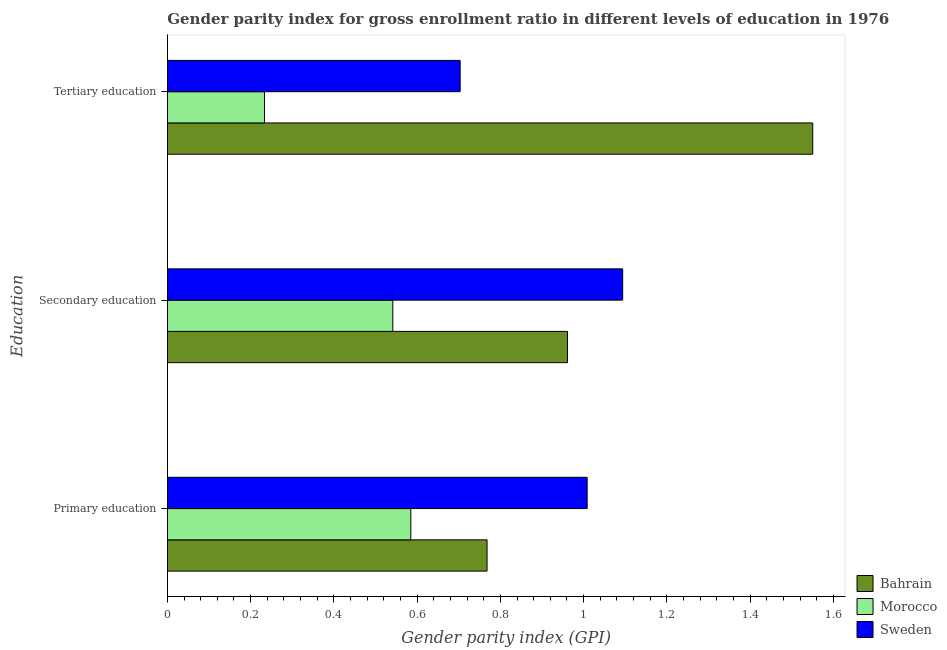How many different coloured bars are there?
Ensure brevity in your answer.  3. How many groups of bars are there?
Your answer should be very brief. 3. How many bars are there on the 2nd tick from the top?
Make the answer very short. 3. How many bars are there on the 1st tick from the bottom?
Keep it short and to the point. 3. What is the gender parity index in tertiary education in Sweden?
Your answer should be very brief. 0.7. Across all countries, what is the maximum gender parity index in secondary education?
Offer a terse response. 1.09. Across all countries, what is the minimum gender parity index in secondary education?
Your answer should be compact. 0.54. In which country was the gender parity index in primary education maximum?
Keep it short and to the point. Sweden. In which country was the gender parity index in secondary education minimum?
Offer a very short reply. Morocco. What is the total gender parity index in tertiary education in the graph?
Keep it short and to the point. 2.49. What is the difference between the gender parity index in tertiary education in Sweden and that in Morocco?
Ensure brevity in your answer.  0.47. What is the difference between the gender parity index in tertiary education in Bahrain and the gender parity index in primary education in Sweden?
Ensure brevity in your answer.  0.54. What is the average gender parity index in primary education per country?
Offer a very short reply. 0.79. What is the difference between the gender parity index in secondary education and gender parity index in primary education in Sweden?
Offer a terse response. 0.09. What is the ratio of the gender parity index in secondary education in Sweden to that in Bahrain?
Offer a very short reply. 1.14. What is the difference between the highest and the second highest gender parity index in tertiary education?
Offer a terse response. 0.85. What is the difference between the highest and the lowest gender parity index in tertiary education?
Your answer should be compact. 1.32. In how many countries, is the gender parity index in secondary education greater than the average gender parity index in secondary education taken over all countries?
Your answer should be compact. 2. What does the 3rd bar from the top in Primary education represents?
Provide a succinct answer. Bahrain. What does the 2nd bar from the bottom in Secondary education represents?
Provide a short and direct response. Morocco. Is it the case that in every country, the sum of the gender parity index in primary education and gender parity index in secondary education is greater than the gender parity index in tertiary education?
Make the answer very short. Yes. Are all the bars in the graph horizontal?
Make the answer very short. Yes. How many countries are there in the graph?
Provide a succinct answer. 3. Are the values on the major ticks of X-axis written in scientific E-notation?
Give a very brief answer. No. Does the graph contain any zero values?
Provide a short and direct response. No. Does the graph contain grids?
Ensure brevity in your answer.  No. Where does the legend appear in the graph?
Your answer should be compact. Bottom right. What is the title of the graph?
Provide a short and direct response. Gender parity index for gross enrollment ratio in different levels of education in 1976. Does "New Caledonia" appear as one of the legend labels in the graph?
Your answer should be compact. No. What is the label or title of the X-axis?
Offer a terse response. Gender parity index (GPI). What is the label or title of the Y-axis?
Make the answer very short. Education. What is the Gender parity index (GPI) of Bahrain in Primary education?
Offer a terse response. 0.77. What is the Gender parity index (GPI) of Morocco in Primary education?
Keep it short and to the point. 0.58. What is the Gender parity index (GPI) of Sweden in Primary education?
Make the answer very short. 1.01. What is the Gender parity index (GPI) in Bahrain in Secondary education?
Your response must be concise. 0.96. What is the Gender parity index (GPI) in Morocco in Secondary education?
Offer a terse response. 0.54. What is the Gender parity index (GPI) in Sweden in Secondary education?
Your answer should be compact. 1.09. What is the Gender parity index (GPI) in Bahrain in Tertiary education?
Make the answer very short. 1.55. What is the Gender parity index (GPI) of Morocco in Tertiary education?
Give a very brief answer. 0.23. What is the Gender parity index (GPI) in Sweden in Tertiary education?
Your answer should be compact. 0.7. Across all Education, what is the maximum Gender parity index (GPI) of Bahrain?
Provide a succinct answer. 1.55. Across all Education, what is the maximum Gender parity index (GPI) in Morocco?
Give a very brief answer. 0.58. Across all Education, what is the maximum Gender parity index (GPI) in Sweden?
Keep it short and to the point. 1.09. Across all Education, what is the minimum Gender parity index (GPI) in Bahrain?
Offer a very short reply. 0.77. Across all Education, what is the minimum Gender parity index (GPI) of Morocco?
Offer a terse response. 0.23. Across all Education, what is the minimum Gender parity index (GPI) of Sweden?
Make the answer very short. 0.7. What is the total Gender parity index (GPI) in Bahrain in the graph?
Offer a terse response. 3.28. What is the total Gender parity index (GPI) of Morocco in the graph?
Offer a terse response. 1.36. What is the total Gender parity index (GPI) of Sweden in the graph?
Make the answer very short. 2.81. What is the difference between the Gender parity index (GPI) in Bahrain in Primary education and that in Secondary education?
Your answer should be compact. -0.19. What is the difference between the Gender parity index (GPI) in Morocco in Primary education and that in Secondary education?
Offer a terse response. 0.04. What is the difference between the Gender parity index (GPI) in Sweden in Primary education and that in Secondary education?
Offer a terse response. -0.09. What is the difference between the Gender parity index (GPI) in Bahrain in Primary education and that in Tertiary education?
Ensure brevity in your answer.  -0.78. What is the difference between the Gender parity index (GPI) of Morocco in Primary education and that in Tertiary education?
Provide a short and direct response. 0.35. What is the difference between the Gender parity index (GPI) in Sweden in Primary education and that in Tertiary education?
Make the answer very short. 0.31. What is the difference between the Gender parity index (GPI) in Bahrain in Secondary education and that in Tertiary education?
Provide a short and direct response. -0.59. What is the difference between the Gender parity index (GPI) of Morocco in Secondary education and that in Tertiary education?
Provide a succinct answer. 0.31. What is the difference between the Gender parity index (GPI) in Sweden in Secondary education and that in Tertiary education?
Make the answer very short. 0.39. What is the difference between the Gender parity index (GPI) in Bahrain in Primary education and the Gender parity index (GPI) in Morocco in Secondary education?
Your answer should be compact. 0.23. What is the difference between the Gender parity index (GPI) of Bahrain in Primary education and the Gender parity index (GPI) of Sweden in Secondary education?
Your answer should be very brief. -0.33. What is the difference between the Gender parity index (GPI) of Morocco in Primary education and the Gender parity index (GPI) of Sweden in Secondary education?
Provide a succinct answer. -0.51. What is the difference between the Gender parity index (GPI) of Bahrain in Primary education and the Gender parity index (GPI) of Morocco in Tertiary education?
Offer a terse response. 0.53. What is the difference between the Gender parity index (GPI) of Bahrain in Primary education and the Gender parity index (GPI) of Sweden in Tertiary education?
Keep it short and to the point. 0.06. What is the difference between the Gender parity index (GPI) in Morocco in Primary education and the Gender parity index (GPI) in Sweden in Tertiary education?
Make the answer very short. -0.12. What is the difference between the Gender parity index (GPI) in Bahrain in Secondary education and the Gender parity index (GPI) in Morocco in Tertiary education?
Ensure brevity in your answer.  0.73. What is the difference between the Gender parity index (GPI) of Bahrain in Secondary education and the Gender parity index (GPI) of Sweden in Tertiary education?
Your response must be concise. 0.26. What is the difference between the Gender parity index (GPI) in Morocco in Secondary education and the Gender parity index (GPI) in Sweden in Tertiary education?
Your response must be concise. -0.16. What is the average Gender parity index (GPI) of Bahrain per Education?
Your response must be concise. 1.09. What is the average Gender parity index (GPI) in Morocco per Education?
Make the answer very short. 0.45. What is the average Gender parity index (GPI) in Sweden per Education?
Your answer should be very brief. 0.94. What is the difference between the Gender parity index (GPI) of Bahrain and Gender parity index (GPI) of Morocco in Primary education?
Your answer should be very brief. 0.18. What is the difference between the Gender parity index (GPI) in Bahrain and Gender parity index (GPI) in Sweden in Primary education?
Keep it short and to the point. -0.24. What is the difference between the Gender parity index (GPI) in Morocco and Gender parity index (GPI) in Sweden in Primary education?
Provide a short and direct response. -0.42. What is the difference between the Gender parity index (GPI) in Bahrain and Gender parity index (GPI) in Morocco in Secondary education?
Provide a succinct answer. 0.42. What is the difference between the Gender parity index (GPI) in Bahrain and Gender parity index (GPI) in Sweden in Secondary education?
Ensure brevity in your answer.  -0.13. What is the difference between the Gender parity index (GPI) of Morocco and Gender parity index (GPI) of Sweden in Secondary education?
Ensure brevity in your answer.  -0.55. What is the difference between the Gender parity index (GPI) of Bahrain and Gender parity index (GPI) of Morocco in Tertiary education?
Your answer should be very brief. 1.32. What is the difference between the Gender parity index (GPI) in Bahrain and Gender parity index (GPI) in Sweden in Tertiary education?
Your answer should be compact. 0.85. What is the difference between the Gender parity index (GPI) of Morocco and Gender parity index (GPI) of Sweden in Tertiary education?
Give a very brief answer. -0.47. What is the ratio of the Gender parity index (GPI) of Bahrain in Primary education to that in Secondary education?
Your answer should be very brief. 0.8. What is the ratio of the Gender parity index (GPI) of Morocco in Primary education to that in Secondary education?
Offer a very short reply. 1.08. What is the ratio of the Gender parity index (GPI) in Sweden in Primary education to that in Secondary education?
Provide a succinct answer. 0.92. What is the ratio of the Gender parity index (GPI) of Bahrain in Primary education to that in Tertiary education?
Your response must be concise. 0.5. What is the ratio of the Gender parity index (GPI) in Morocco in Primary education to that in Tertiary education?
Keep it short and to the point. 2.51. What is the ratio of the Gender parity index (GPI) in Sweden in Primary education to that in Tertiary education?
Make the answer very short. 1.43. What is the ratio of the Gender parity index (GPI) of Bahrain in Secondary education to that in Tertiary education?
Your response must be concise. 0.62. What is the ratio of the Gender parity index (GPI) in Morocco in Secondary education to that in Tertiary education?
Offer a terse response. 2.32. What is the ratio of the Gender parity index (GPI) in Sweden in Secondary education to that in Tertiary education?
Provide a short and direct response. 1.56. What is the difference between the highest and the second highest Gender parity index (GPI) in Bahrain?
Keep it short and to the point. 0.59. What is the difference between the highest and the second highest Gender parity index (GPI) in Morocco?
Make the answer very short. 0.04. What is the difference between the highest and the second highest Gender parity index (GPI) of Sweden?
Your answer should be very brief. 0.09. What is the difference between the highest and the lowest Gender parity index (GPI) in Bahrain?
Ensure brevity in your answer.  0.78. What is the difference between the highest and the lowest Gender parity index (GPI) of Morocco?
Make the answer very short. 0.35. What is the difference between the highest and the lowest Gender parity index (GPI) in Sweden?
Make the answer very short. 0.39. 